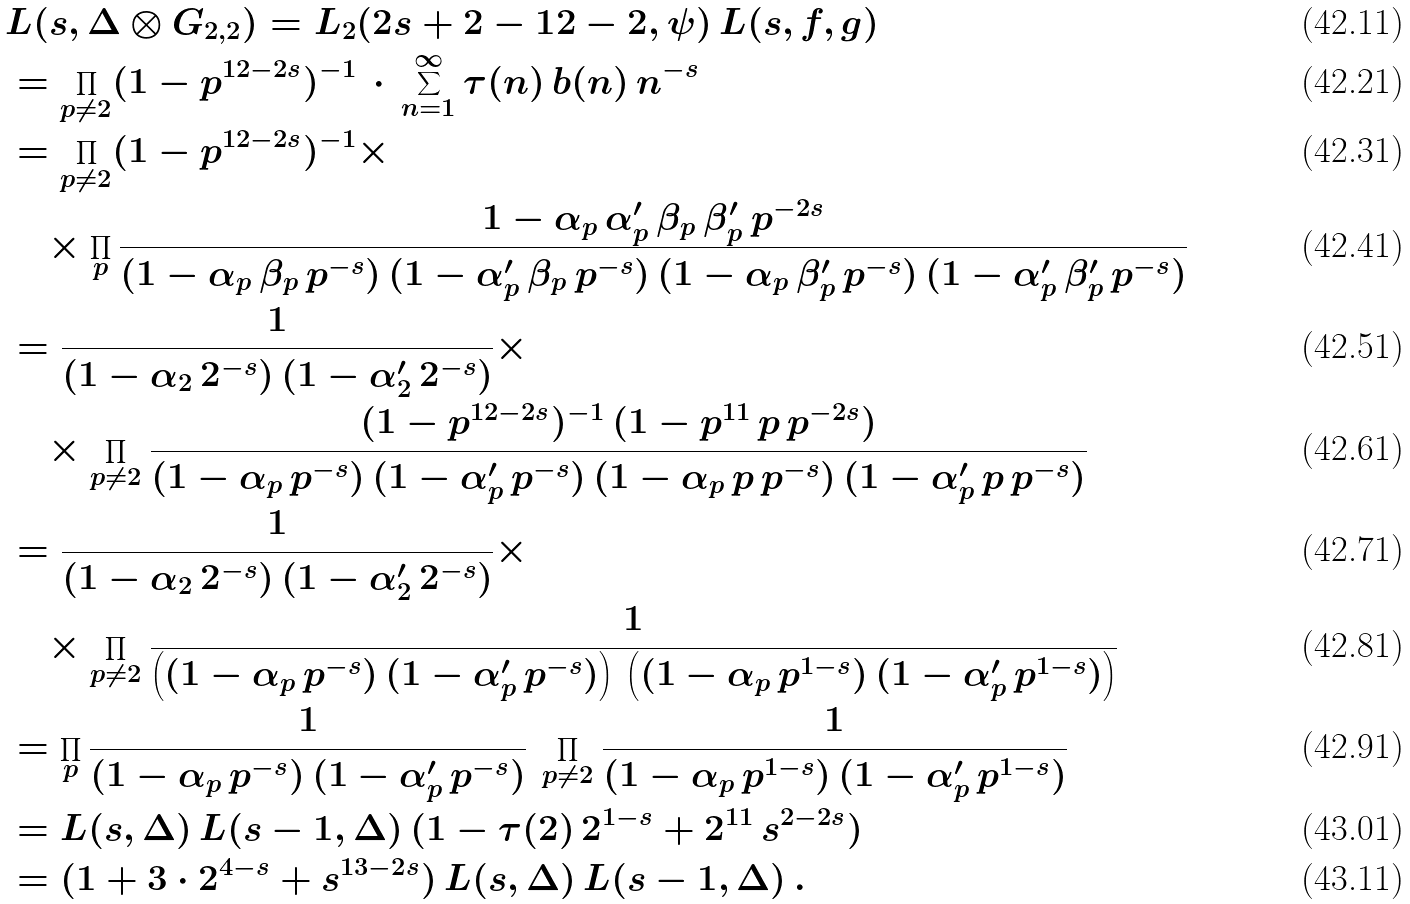<formula> <loc_0><loc_0><loc_500><loc_500>& L ( s , \Delta \otimes G _ { 2 , 2 } ) = L _ { 2 } ( 2 s + 2 - 1 2 - 2 , \psi ) \, L ( s , f , g ) \\ & = \prod _ { p \neq 2 } ( 1 - p ^ { 1 2 - 2 s } ) ^ { - 1 } \, \cdot \, \sum _ { n = 1 } ^ { \infty } \tau ( n ) \, b ( n ) \, n ^ { - s } \\ & = \prod _ { p \neq 2 } ( 1 - p ^ { 1 2 - 2 s } ) ^ { - 1 } \times \\ & \quad \times \prod _ { p } \frac { 1 - \alpha _ { p } \, \alpha _ { p } ^ { \prime } \, \beta _ { p } \, \beta _ { p } ^ { \prime } \, p ^ { - 2 s } } { ( 1 - \alpha _ { p } \, \beta _ { p } \, p ^ { - s } ) \, ( 1 - \alpha _ { p } ^ { \prime } \, \beta _ { p } \, p ^ { - s } ) \, ( 1 - \alpha _ { p } \, \beta _ { p } ^ { \prime } \, p ^ { - s } ) \, ( 1 - \alpha _ { p } ^ { \prime } \, \beta _ { p } ^ { \prime } \, p ^ { - s } ) } \\ & = \frac { 1 } { ( 1 - \alpha _ { 2 } \, 2 ^ { - s } ) \, ( 1 - \alpha _ { 2 } ^ { \prime } \, 2 ^ { - s } ) } \times \\ & \quad \times \prod _ { p \neq 2 } \frac { ( 1 - p ^ { 1 2 - 2 s } ) ^ { - 1 } \, ( 1 - p ^ { 1 1 } \, p \, p ^ { - 2 s } ) } { ( 1 - \alpha _ { p } \, p ^ { - s } ) \, ( 1 - \alpha _ { p } ^ { \prime } \, p ^ { - s } ) \, ( 1 - \alpha _ { p } \, p \, p ^ { - s } ) \, ( 1 - \alpha _ { p } ^ { \prime } \, p \, p ^ { - s } ) } \\ & = \frac { 1 } { ( 1 - \alpha _ { 2 } \, 2 ^ { - s } ) \, ( 1 - \alpha _ { 2 } ^ { \prime } \, 2 ^ { - s } ) } \times \\ & \quad \times \prod _ { p \neq 2 } \frac { 1 } { \left ( ( 1 - \alpha _ { p } \, p ^ { - s } ) \, ( 1 - \alpha _ { p } ^ { \prime } \, p ^ { - s } ) \right ) \, \left ( ( 1 - \alpha _ { p } \, p ^ { 1 - s } ) \, ( 1 - \alpha _ { p } ^ { \prime } \, p ^ { 1 - s } ) \right ) } \\ & = \prod _ { p } \frac { 1 } { ( 1 - \alpha _ { p } \, p ^ { - s } ) \, ( 1 - \alpha _ { p } ^ { \prime } \, p ^ { - s } ) } \, \prod _ { p \neq 2 } \frac { 1 } { ( 1 - \alpha _ { p } \, p ^ { 1 - s } ) \, ( 1 - \alpha _ { p } ^ { \prime } \, p ^ { 1 - s } ) } \\ & = L ( s , \Delta ) \, L ( s - 1 , \Delta ) \, ( 1 - \tau ( 2 ) \, 2 ^ { 1 - s } + 2 ^ { 1 1 } \, s ^ { 2 - 2 s } ) \\ & = ( 1 + 3 \cdot 2 ^ { 4 - s } + s ^ { 1 3 - 2 s } ) \, L ( s , \Delta ) \, L ( s - 1 , \Delta ) \, .</formula> 